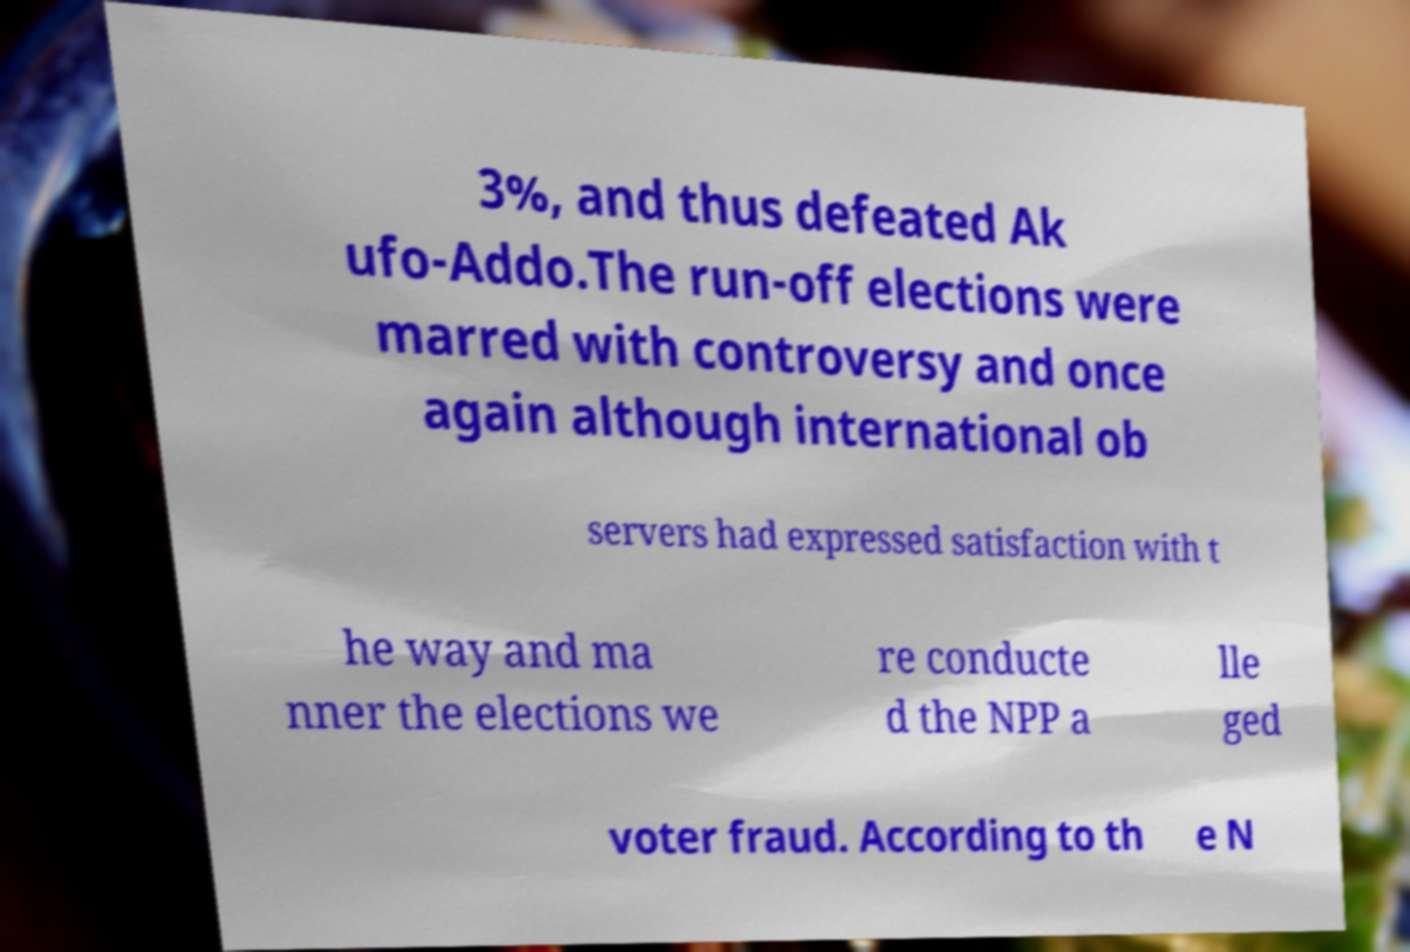For documentation purposes, I need the text within this image transcribed. Could you provide that? 3%, and thus defeated Ak ufo-Addo.The run-off elections were marred with controversy and once again although international ob servers had expressed satisfaction with t he way and ma nner the elections we re conducte d the NPP a lle ged voter fraud. According to th e N 